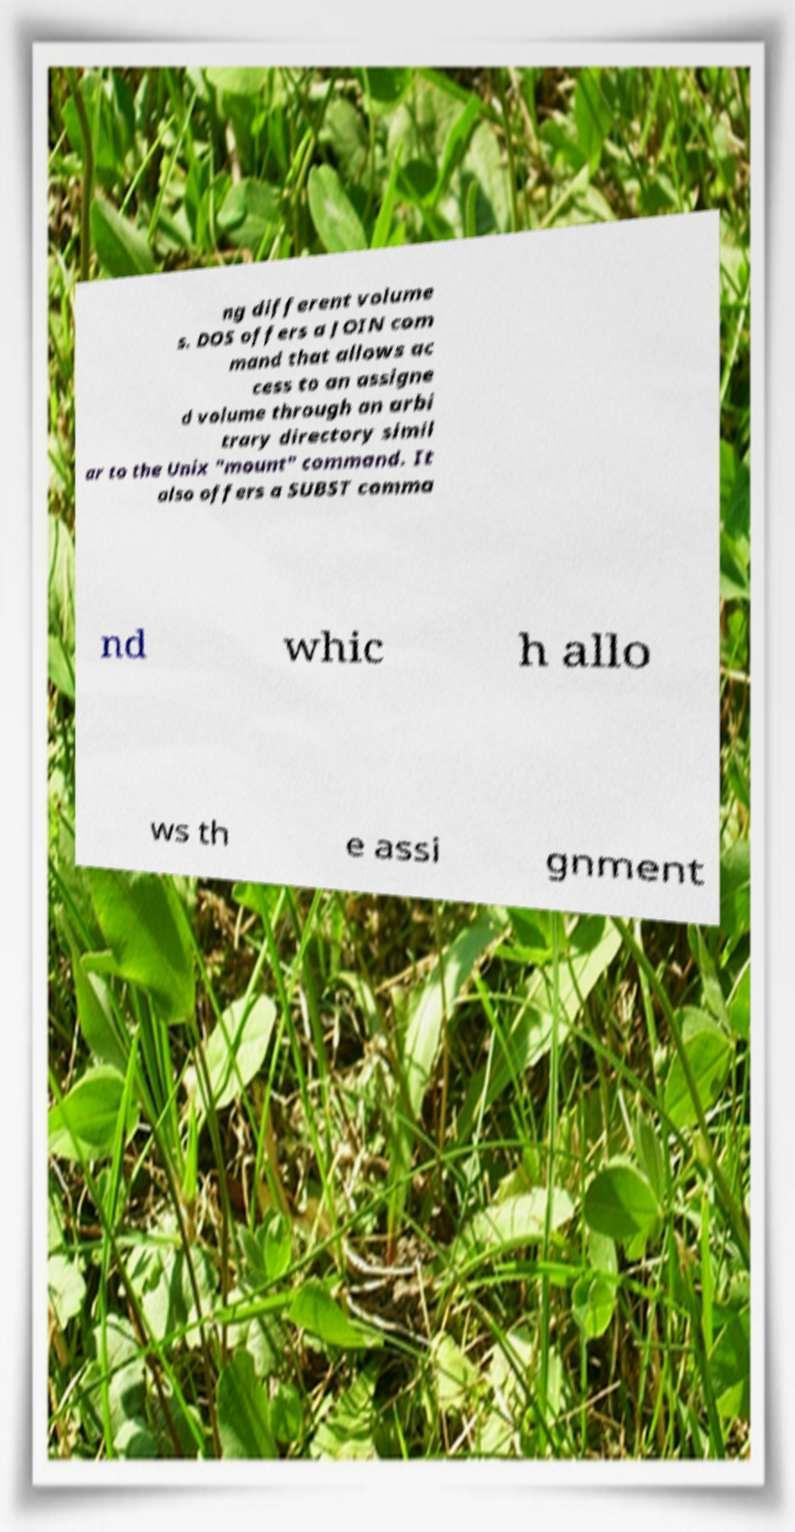Can you read and provide the text displayed in the image?This photo seems to have some interesting text. Can you extract and type it out for me? ng different volume s. DOS offers a JOIN com mand that allows ac cess to an assigne d volume through an arbi trary directory simil ar to the Unix "mount" command. It also offers a SUBST comma nd whic h allo ws th e assi gnment 